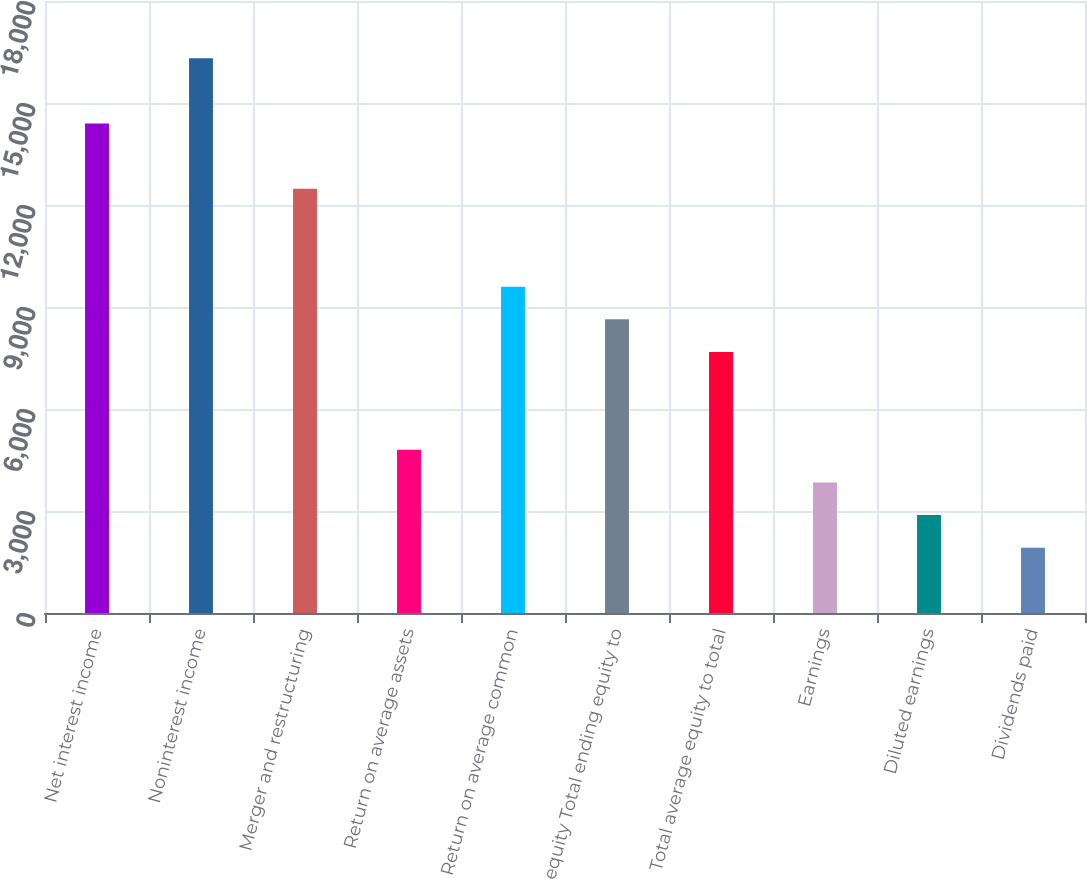<chart> <loc_0><loc_0><loc_500><loc_500><bar_chart><fcel>Net interest income<fcel>Noninterest income<fcel>Merger and restructuring<fcel>Return on average assets<fcel>Return on average common<fcel>equity Total ending equity to<fcel>Total average equity to total<fcel>Earnings<fcel>Diluted earnings<fcel>Dividends paid<nl><fcel>14396.9<fcel>16316.5<fcel>12477.4<fcel>4799.14<fcel>9598.04<fcel>8638.26<fcel>7678.48<fcel>3839.36<fcel>2879.58<fcel>1919.8<nl></chart> 